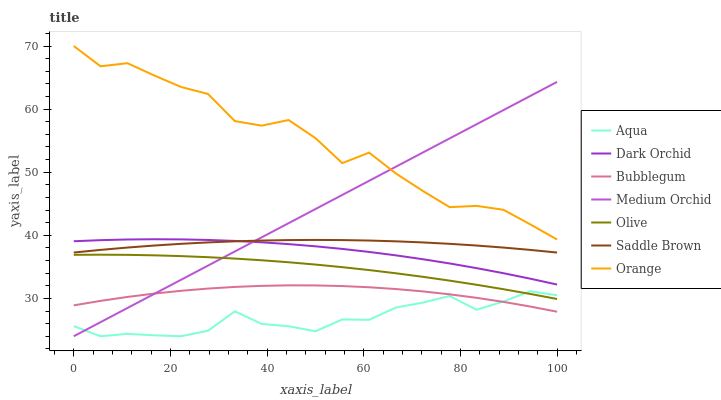Does Aqua have the minimum area under the curve?
Answer yes or no. Yes. Does Orange have the maximum area under the curve?
Answer yes or no. Yes. Does Bubblegum have the minimum area under the curve?
Answer yes or no. No. Does Bubblegum have the maximum area under the curve?
Answer yes or no. No. Is Medium Orchid the smoothest?
Answer yes or no. Yes. Is Orange the roughest?
Answer yes or no. Yes. Is Aqua the smoothest?
Answer yes or no. No. Is Aqua the roughest?
Answer yes or no. No. Does Bubblegum have the lowest value?
Answer yes or no. No. Does Orange have the highest value?
Answer yes or no. Yes. Does Bubblegum have the highest value?
Answer yes or no. No. Is Saddle Brown less than Orange?
Answer yes or no. Yes. Is Orange greater than Bubblegum?
Answer yes or no. Yes. Does Medium Orchid intersect Saddle Brown?
Answer yes or no. Yes. Is Medium Orchid less than Saddle Brown?
Answer yes or no. No. Is Medium Orchid greater than Saddle Brown?
Answer yes or no. No. Does Saddle Brown intersect Orange?
Answer yes or no. No. 